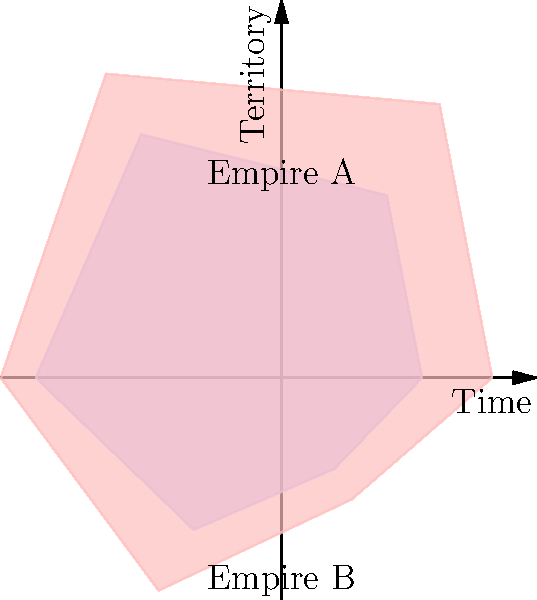The polar area charts above represent the territorial expansion of two empires over six time periods. Which of the following statements most accurately describes the limitations of using this visualization to compare the historical development of these empires? To critically analyze this visualization from an academic historian's perspective, we need to consider several factors:

1. Oversimplification: The polar area chart reduces complex historical processes to simple geometric shapes, potentially obscuring important nuances in territorial expansion.

2. Lack of context: The visualization doesn't provide information about the specific historical events, socio-economic factors, or geopolitical circumstances that influenced the empires' expansion or contraction.

3. Temporal ambiguity: While the chart shows six time periods, it doesn't specify the duration of each period or whether they are evenly spaced, which could lead to misinterpretation of the rate of expansion.

4. Geographical inaccuracy: The circular representation doesn't account for the actual geography or topography of the territories, which could have significantly influenced expansion patterns.

5. Quantitative imprecision: The area of each sector represents the territory, but it's unclear how this area corresponds to actual land measurements or population.

6. Comparative limitations: While the chart allows for a quick visual comparison, it doesn't provide detailed information about the nature of the territories (e.g., resource-rich vs. barren lands) or the methods of acquisition (e.g., conquest, treaties, colonization).

7. Cultural oversimplification: The chart reduces complex civilizations to simple labels (Empire A and Empire B), potentially reinforcing a Eurocentric or overly generalized view of history.

8. Lack of uncertainty representation: Historical data often comes with a degree of uncertainty, especially for older time periods, which is not reflected in this definitive visual representation.

Given these limitations, the most accurate statement would be that this visualization oversimplifies complex historical processes and lacks crucial contextual information necessary for a nuanced understanding of imperial expansion.
Answer: Oversimplification and lack of crucial historical context 